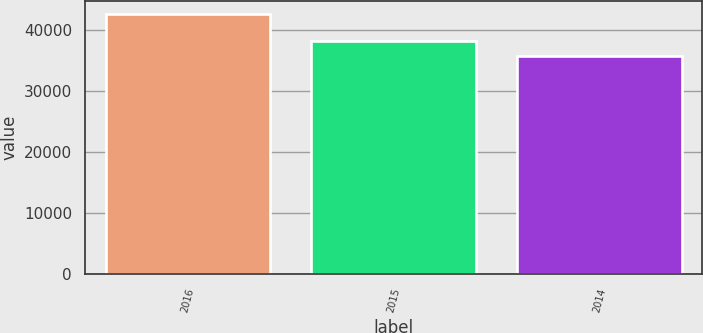Convert chart. <chart><loc_0><loc_0><loc_500><loc_500><bar_chart><fcel>2016<fcel>2015<fcel>2014<nl><fcel>42663<fcel>38178<fcel>35731<nl></chart> 